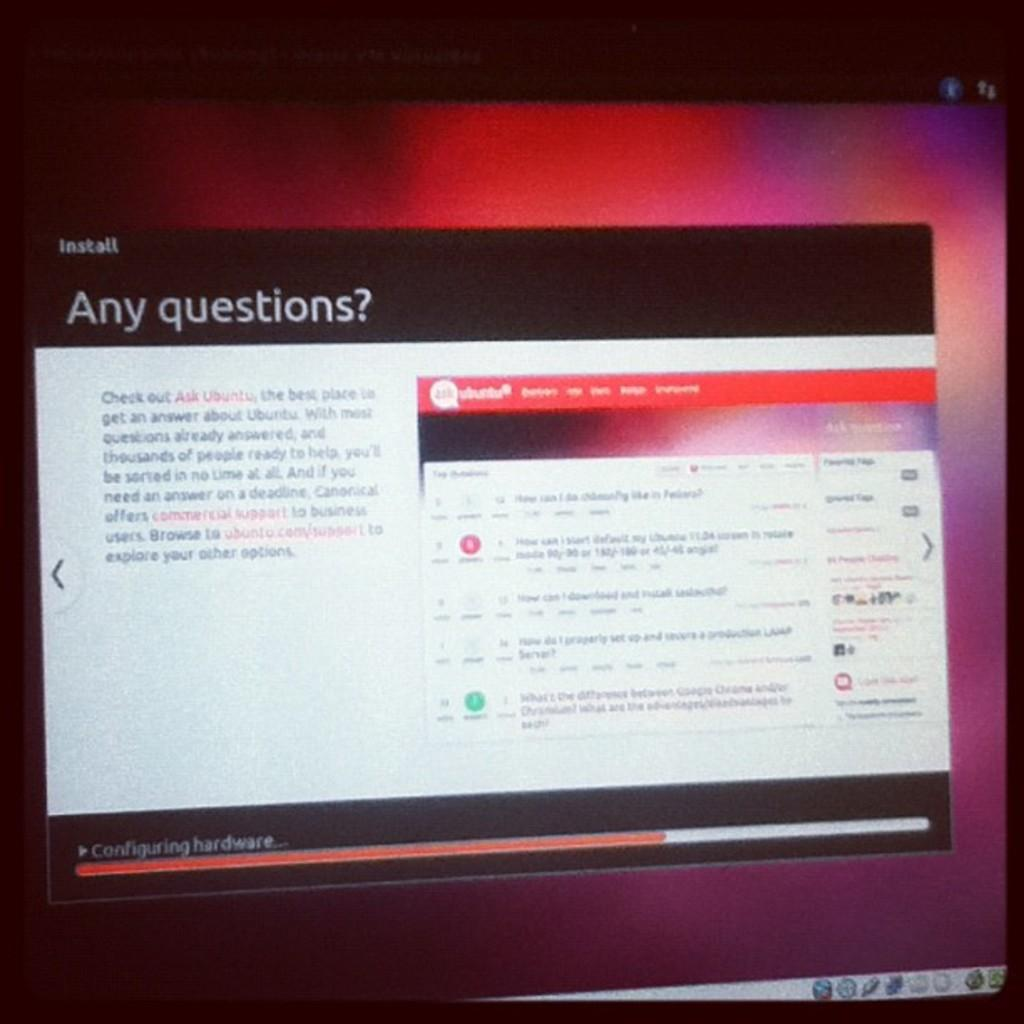Provide a one-sentence caption for the provided image. A computer screen with a window up saying "Any questions?". 